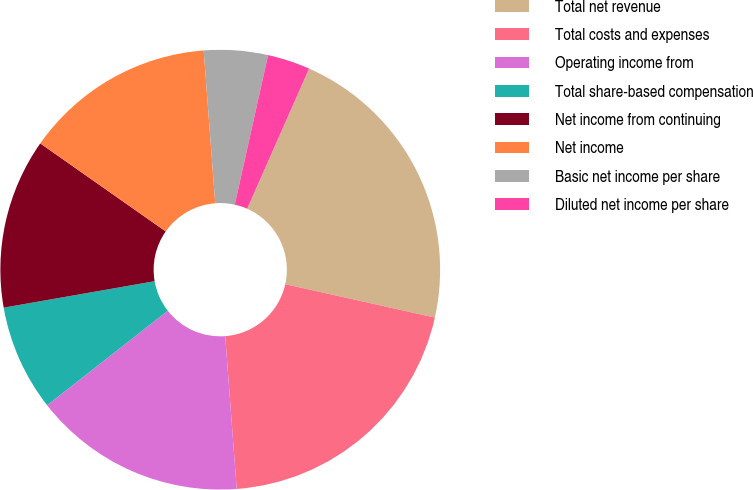Convert chart to OTSL. <chart><loc_0><loc_0><loc_500><loc_500><pie_chart><fcel>Total net revenue<fcel>Total costs and expenses<fcel>Operating income from<fcel>Total share-based compensation<fcel>Net income from continuing<fcel>Net income<fcel>Basic net income per share<fcel>Diluted net income per share<nl><fcel>21.87%<fcel>20.31%<fcel>15.62%<fcel>7.81%<fcel>12.5%<fcel>14.06%<fcel>4.69%<fcel>3.13%<nl></chart> 